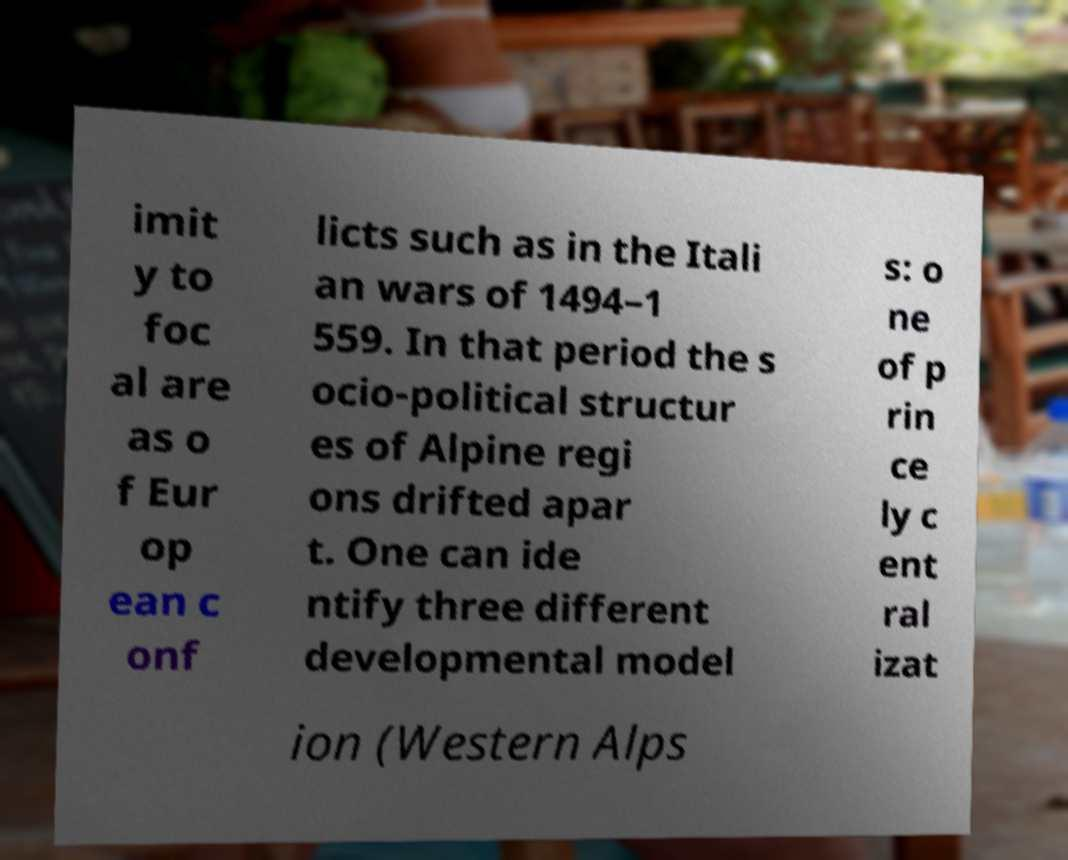What messages or text are displayed in this image? I need them in a readable, typed format. imit y to foc al are as o f Eur op ean c onf licts such as in the Itali an wars of 1494–1 559. In that period the s ocio-political structur es of Alpine regi ons drifted apar t. One can ide ntify three different developmental model s: o ne of p rin ce ly c ent ral izat ion (Western Alps 